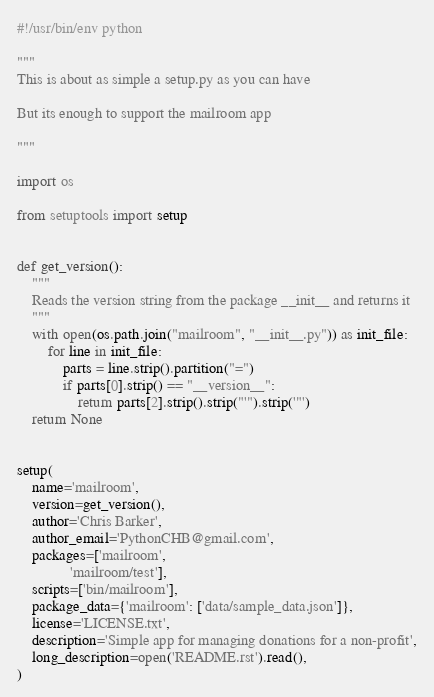Convert code to text. <code><loc_0><loc_0><loc_500><loc_500><_Python_>#!/usr/bin/env python

"""
This is about as simple a setup.py as you can have

But its enough to support the mailroom app

"""

import os

from setuptools import setup


def get_version():
    """
    Reads the version string from the package __init__ and returns it
    """
    with open(os.path.join("mailroom", "__init__.py")) as init_file:
        for line in init_file:
            parts = line.strip().partition("=")
            if parts[0].strip() == "__version__":
                return parts[2].strip().strip("'").strip('"')
    return None


setup(
    name='mailroom',
    version=get_version(),
    author='Chris Barker',
    author_email='PythonCHB@gmail.com',
    packages=['mailroom',
              'mailroom/test'],
    scripts=['bin/mailroom'],
    package_data={'mailroom': ['data/sample_data.json']},
    license='LICENSE.txt',
    description='Simple app for managing donations for a non-profit',
    long_description=open('README.rst').read(),
)
</code> 